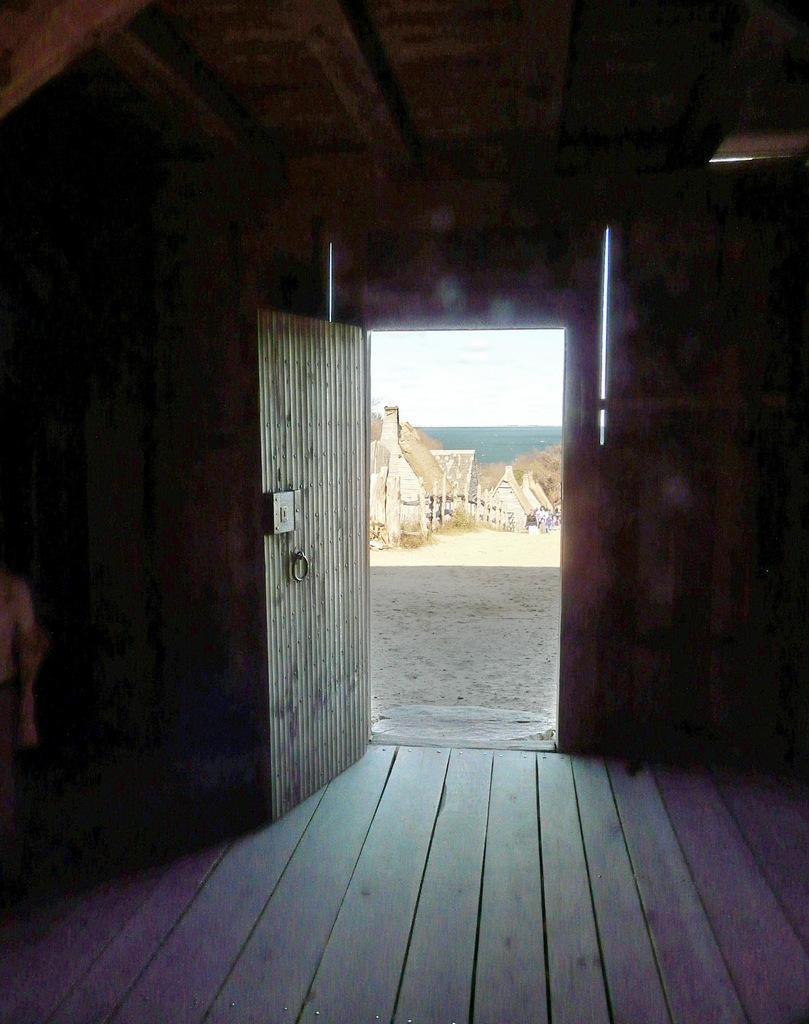Describe this image in one or two sentences. This image consists of a door. This looks like a room, which is built with wood. From that door, we can see, there is the sky outside. 